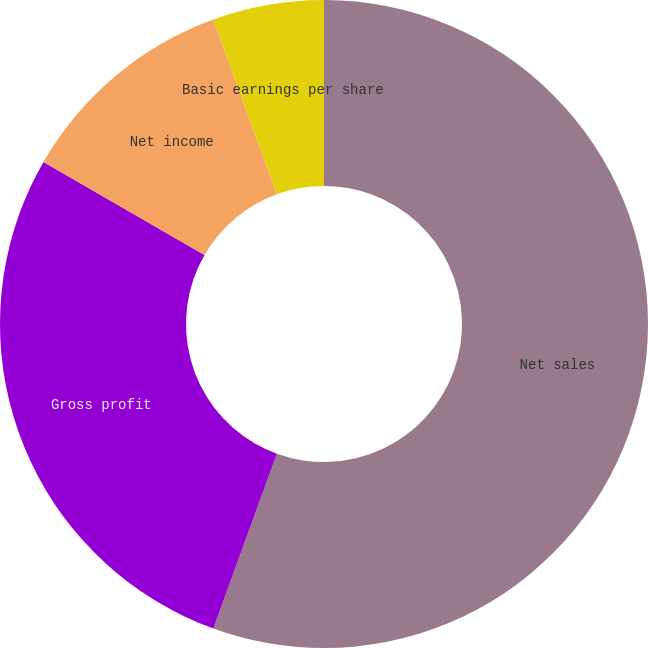Convert chart. <chart><loc_0><loc_0><loc_500><loc_500><pie_chart><fcel>Net sales<fcel>Gross profit<fcel>Net income<fcel>Basic earnings per share<fcel>Diluted earnings per share<nl><fcel>55.55%<fcel>27.79%<fcel>11.11%<fcel>5.55%<fcel>0.0%<nl></chart> 